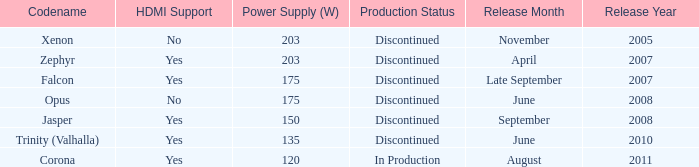Is Jasper being producted? No. 